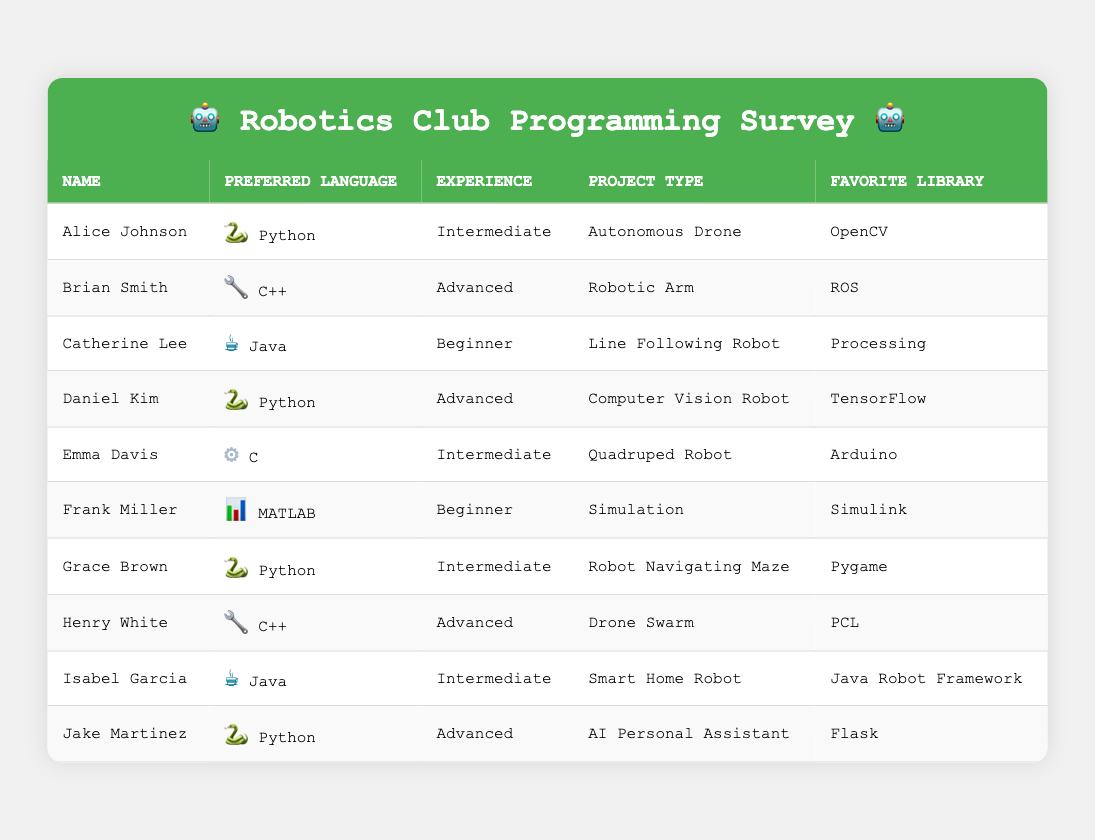What is the most preferred programming language among the participants? By looking at the table, Python appears the most frequently, listed next to Alice Johnson, Daniel Kim, Grace Brown, and Jake Martinez. In total, there are four participants who prefer Python.
Answer: Python How many participants have an advanced experience level? In the table, the participants with an advanced experience level are Brian Smith, Daniel Kim, Henry White, and Jake Martinez. Counting them reveals there are four in total.
Answer: 4 Which favorite library is associated with the participant working on a Drone Swarm project? Looking at the table, the participant working on the Drone Swarm project is Henry White, and his favorite library is PCL.
Answer: PCL Is any participant's preferred language MATLAB? By examining the table, I can see that Frank Miller has MATLAB listed as his preferred language, confirming that there is a participant with MATLAB.
Answer: Yes What is the experience level of participants who prefer Java? The table shows that Catherine Lee is a Beginner and Isabel Garcia is Intermediate, indicating that the experience levels of Java participants vary.
Answer: Beginner and Intermediate Which programming language has the least number of users according to this survey? By checking all entries, both C and MATLAB are utilized by only one participant each (Emma Davis and Frank Miller respectively), indicating they both have the least users.
Answer: C and MATLAB What is the average experience level of participants who prefer Python? Looking at the table, the experience levels of Python users are Intermediate (Alice Johnson, Grace Brown), and Advanced (Daniel Kim, Jake Martinez). Assigning values (Beginner=1, Intermediate=2, Advanced=3) results in (2 + 2 + 3 + 3) = 10. There are four Python users, hence the average is 10/4 = 2.5, which corresponds to an experience level between Intermediate and Advanced.
Answer: 2.5 How many different project types are represented in the table? By surveying the project types listed—Autonomous Drone, Robotic Arm, Line Following Robot, Computer Vision Robot, Quadruped Robot, Simulation, Robot Navigating Maze, Drone Swarm, Smart Home Robot, and AI Personal Assistant—there are ten distinct types.
Answer: 10 Are there more beginners or intermediates among the participants? Checking the experience levels, there are three Beginners (Catherine Lee, Frank Miller) and four Intermediates (Alice Johnson, Emma Davis, Grace Brown, Isabel Garcia). This clearly shows that there are more Intermediate participants than Beginners.
Answer: Intermediates What is the favorite library of the participant with the highest experience level? By checking the experience levels, both Brian Smith and Henry White are categorized as Advanced, and their favorite libraries are ROS and PCL, respectively. Both modules represent the highest experience category.
Answer: ROS and PCL 